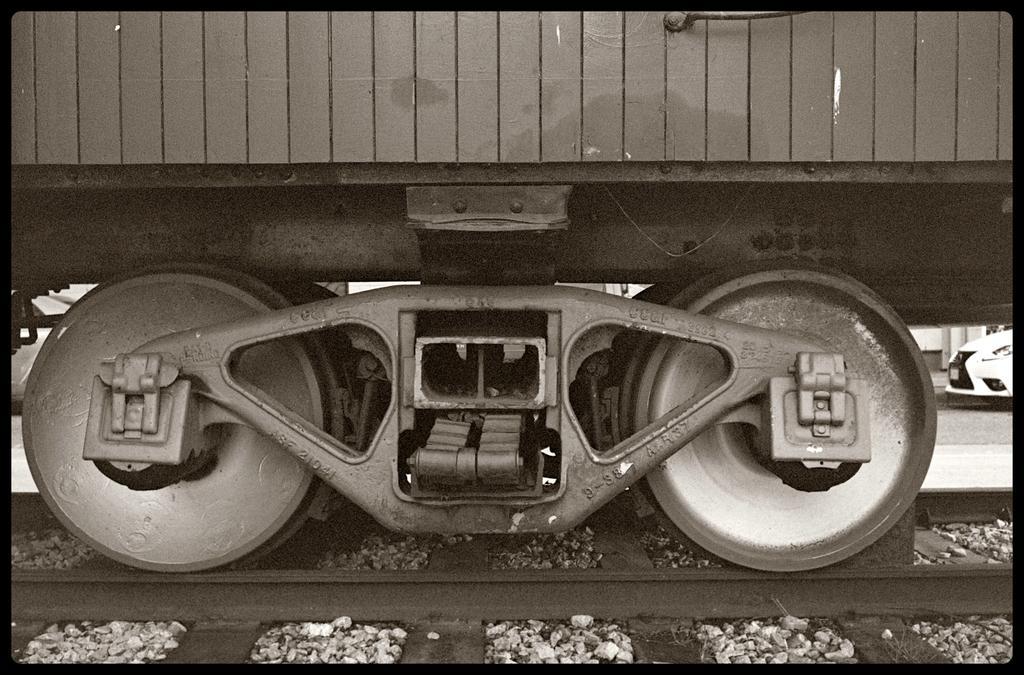Could you give a brief overview of what you see in this image? This image consists of a train. In the front, we can see the wheels on the train. At the bottom, there are tracks along with the stones. On the right, there is a car in white color. 